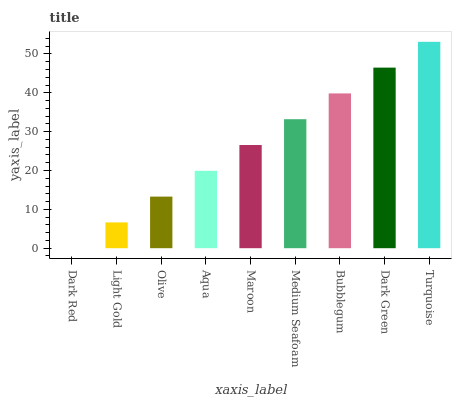Is Light Gold the minimum?
Answer yes or no. No. Is Light Gold the maximum?
Answer yes or no. No. Is Light Gold greater than Dark Red?
Answer yes or no. Yes. Is Dark Red less than Light Gold?
Answer yes or no. Yes. Is Dark Red greater than Light Gold?
Answer yes or no. No. Is Light Gold less than Dark Red?
Answer yes or no. No. Is Maroon the high median?
Answer yes or no. Yes. Is Maroon the low median?
Answer yes or no. Yes. Is Light Gold the high median?
Answer yes or no. No. Is Aqua the low median?
Answer yes or no. No. 